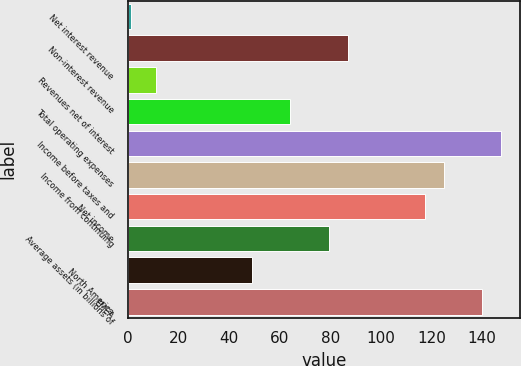Convert chart to OTSL. <chart><loc_0><loc_0><loc_500><loc_500><bar_chart><fcel>Net interest revenue<fcel>Non-interest revenue<fcel>Revenues net of interest<fcel>Total operating expenses<fcel>Income before taxes and<fcel>Income from continuing<fcel>Net income<fcel>Average assets (in billions of<fcel>North America<fcel>EMEA<nl><fcel>1<fcel>87<fcel>11<fcel>64.2<fcel>147.8<fcel>125<fcel>117.4<fcel>79.4<fcel>49<fcel>140.2<nl></chart> 